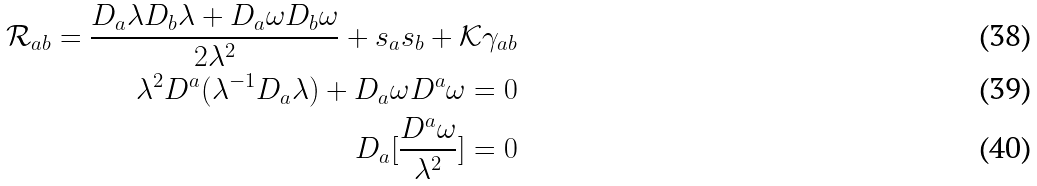Convert formula to latex. <formula><loc_0><loc_0><loc_500><loc_500>\mathcal { R } _ { a b } = \frac { D _ { a } \lambda D _ { b } \lambda + D _ { a } \omega D _ { b } \omega } { 2 \lambda ^ { 2 } } + s _ { a } s _ { b } + \mathcal { K } \gamma _ { a b } & \\ \lambda ^ { 2 } D ^ { a } ( \lambda ^ { - 1 } D _ { a } \lambda ) + D _ { a } \omega D ^ { a } \omega = 0 & \\ D _ { a } [ \frac { D ^ { a } \omega } { \lambda ^ { 2 } } ] = 0 &</formula> 